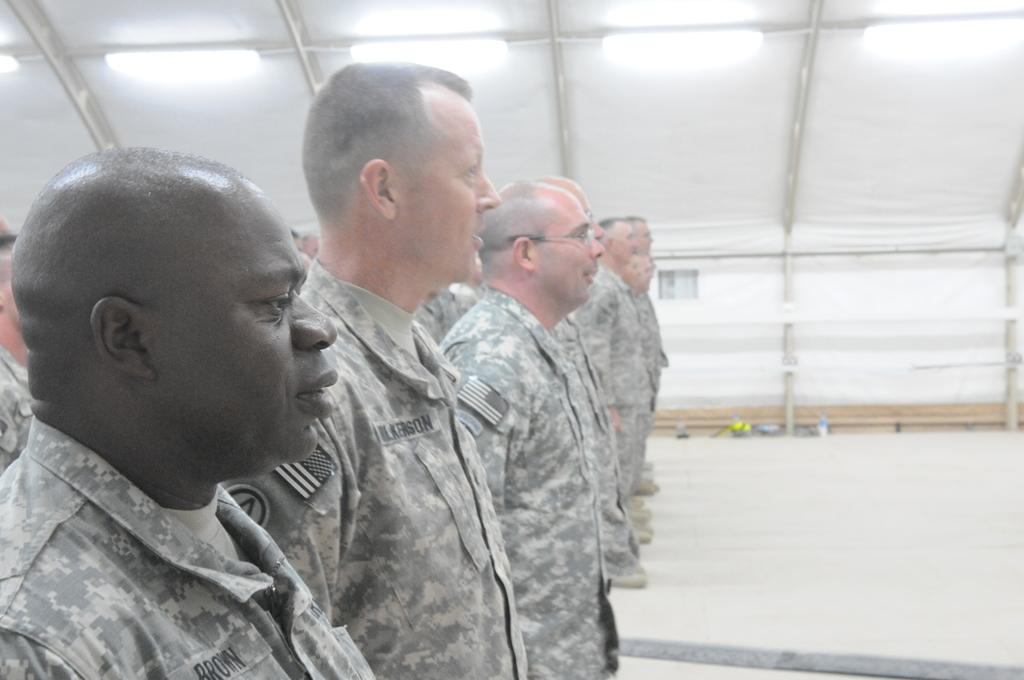What are the men in the image wearing? The men in the image are wearing uniforms. What are the men doing in the image? The men are standing. In which direction are the men facing in the image? The men are facing towards the right side of the image. What color tint can be seen in the background of the image? There is a white color tint in the background of the image. Can you see a giraffe in the image? No, there is no giraffe present in the image. What type of stitch is being used by the men in the image? The men in the image are not engaged in any stitching activity, so it is not possible to determine the type of stitch being used. 